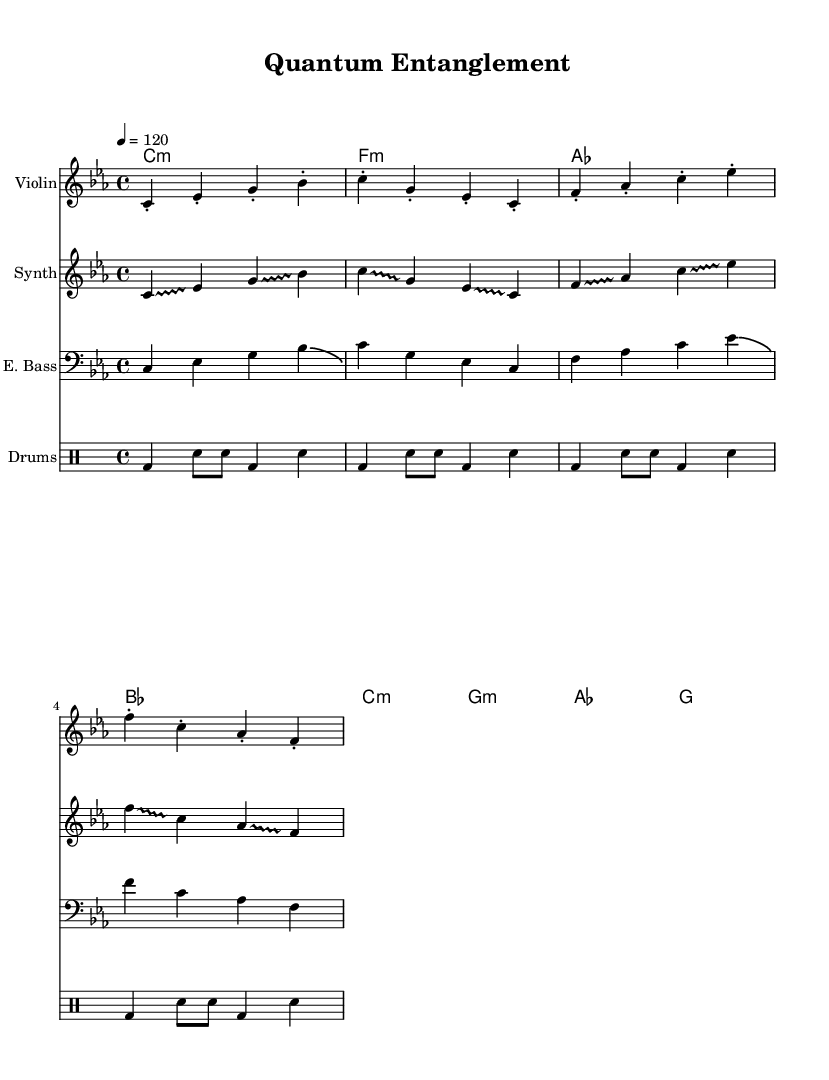What is the key signature of this music? The key signature is indicated by the presence of flattened notes in the music. In this sheet, G flat, B flat, E flat, and A flat are present, confirming the key signature of C minor.
Answer: C minor What is the time signature of this music? The time signature is shown at the beginning of the score, specifically indicating that there are four beats per measure and the quarter note gets one beat. This is denoted as 4/4.
Answer: 4/4 What is the tempo marking in this music? The tempo marking is indicated at the start of the score, representing how fast the piece should be played. The marking states that the tempo is 120 beats per minute, which means a quarter note gets 120 beats.
Answer: 120 How many measures are in the piece? To find the number of measures, you can count the groups of bars marked in the music. There are eight measures present in the score from the parts shown.
Answer: 8 What is the primary mood conveyed by the synthesizer part? The synthesizer part features glissando effects between notes that create a fluid and ethereal sound, suggesting a dreamy or ambient mood associated with the concept of quantum entanglement.
Answer: Dreamy What is the role of the drum machine in this piece? The drum machine provides a consistent rhythmic foundation throughout the piece, with a pattern that establishes the tempo and drives the overall energy of the music.
Answer: Foundation What style of fusion is represented in this score? This score exemplifies a blending of classical elements with electronic sounds, creating a genre known as electro-classical fusion, inspired by concepts from physics like quantum entanglement.
Answer: Electro-classical fusion 